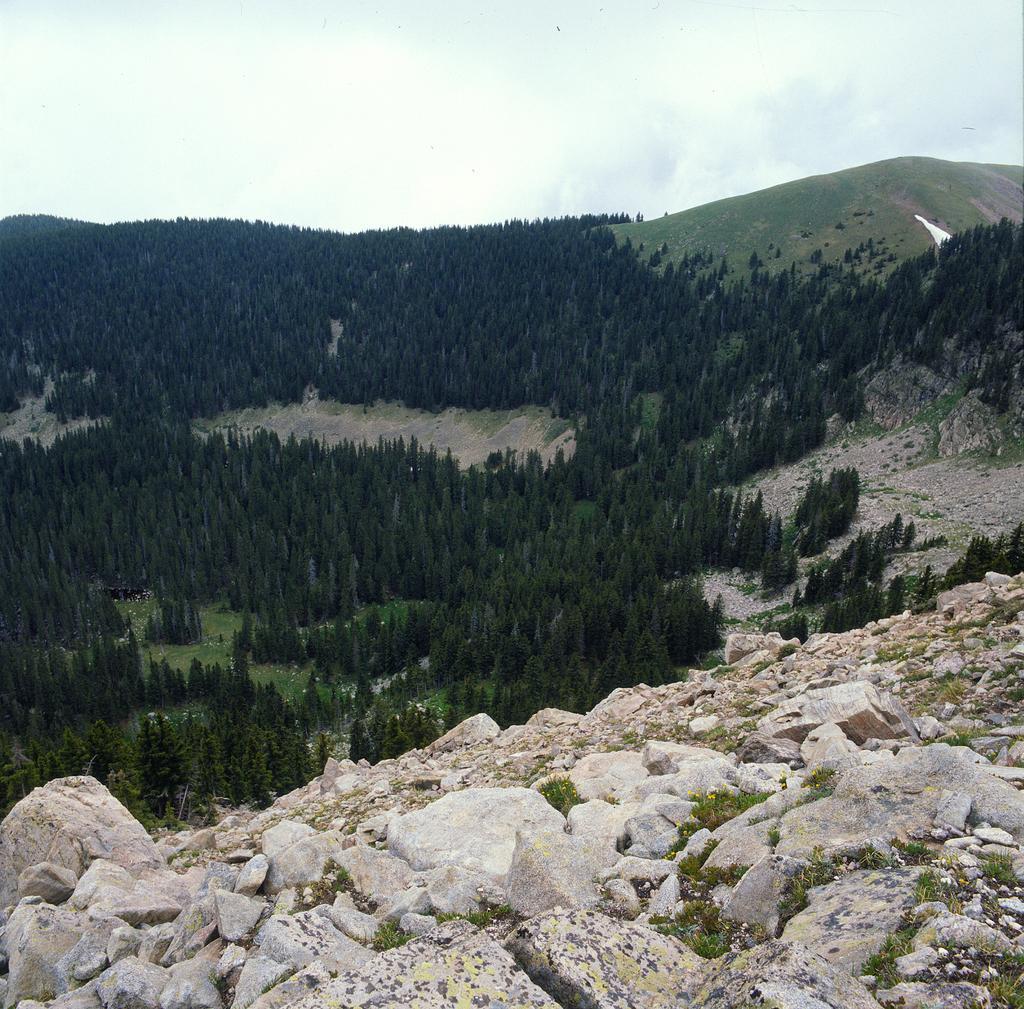In one or two sentences, can you explain what this image depicts? In this image we can see some stones, the rocks, a group of trees on the hill, grass and the sky which looks cloudy. 